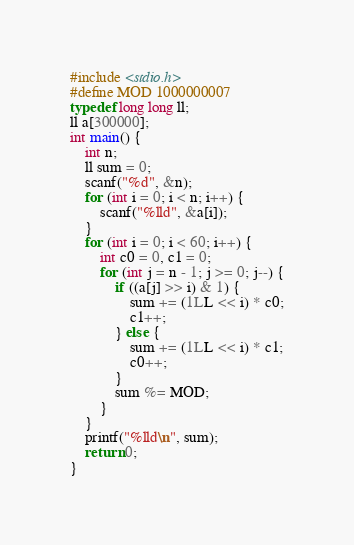<code> <loc_0><loc_0><loc_500><loc_500><_C_>#include <stdio.h>
#define MOD 1000000007
typedef long long ll;
ll a[300000];
int main() {
	int n;
	ll sum = 0;
	scanf("%d", &n);
	for (int i = 0; i < n; i++) {
		scanf("%lld", &a[i]);
	}
	for (int i = 0; i < 60; i++) {
		int c0 = 0, c1 = 0;
		for (int j = n - 1; j >= 0; j--) {
			if ((a[j] >> i) & 1) {
				sum += (1LL << i) * c0;
				c1++;
			} else {
				sum += (1LL << i) * c1;
				c0++;
			}
			sum %= MOD;
		}
	}
	printf("%lld\n", sum);
	return 0;
}</code> 